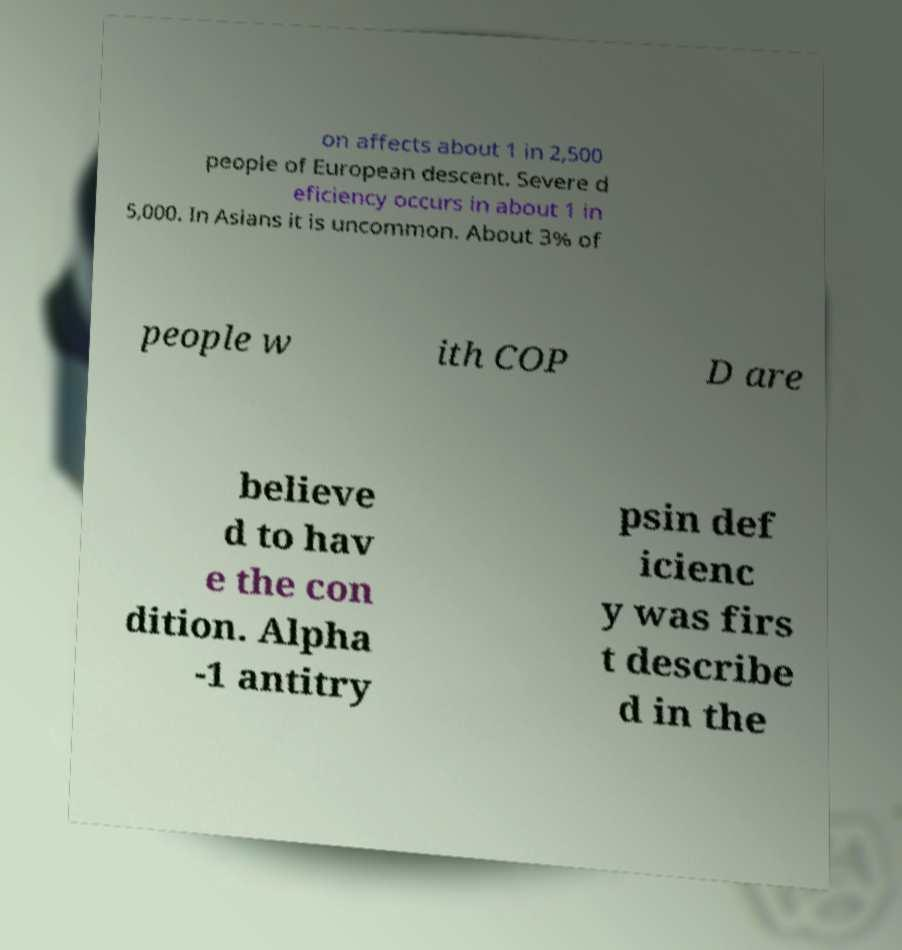There's text embedded in this image that I need extracted. Can you transcribe it verbatim? on affects about 1 in 2,500 people of European descent. Severe d eficiency occurs in about 1 in 5,000. In Asians it is uncommon. About 3% of people w ith COP D are believe d to hav e the con dition. Alpha -1 antitry psin def icienc y was firs t describe d in the 